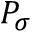Convert formula to latex. <formula><loc_0><loc_0><loc_500><loc_500>P _ { \sigma }</formula> 